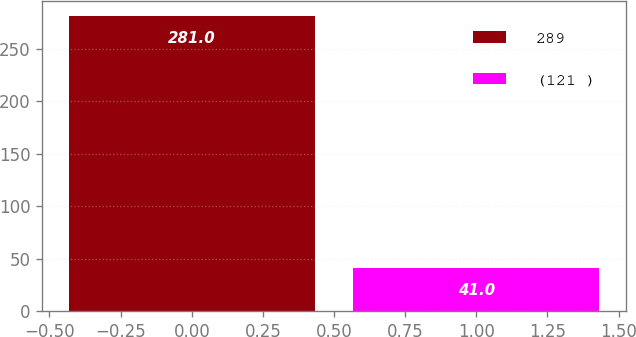Convert chart. <chart><loc_0><loc_0><loc_500><loc_500><bar_chart><fcel>289<fcel>(121 )<nl><fcel>281<fcel>41<nl></chart> 